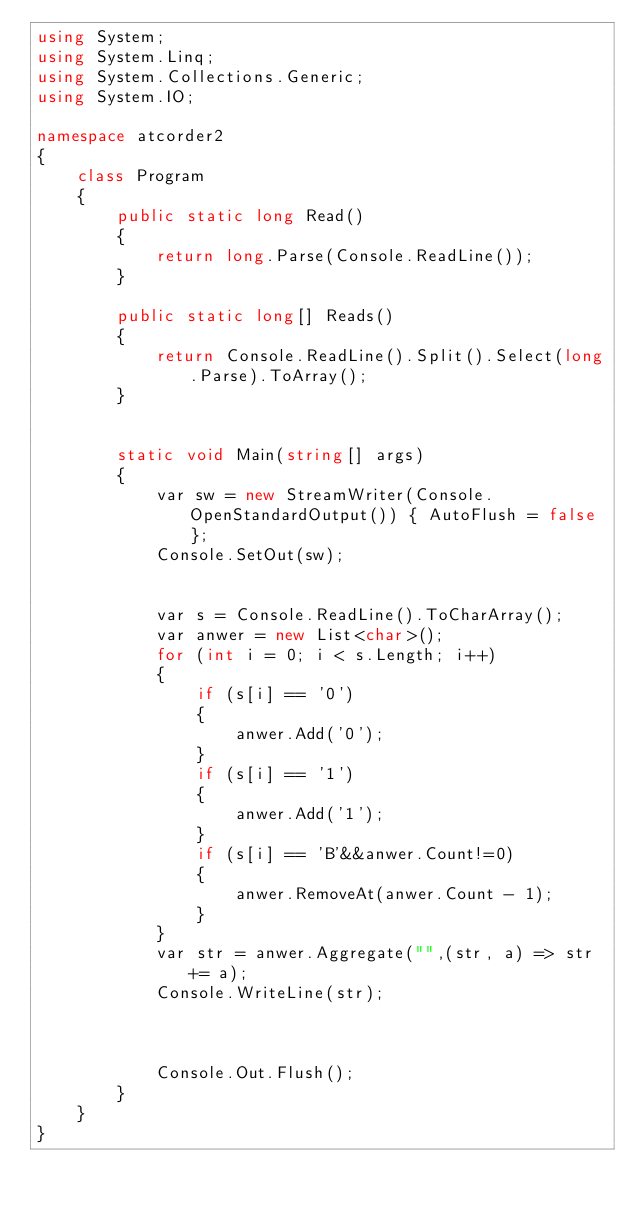Convert code to text. <code><loc_0><loc_0><loc_500><loc_500><_C#_>using System;
using System.Linq;
using System.Collections.Generic;
using System.IO;

namespace atcorder2
{
    class Program
    {
        public static long Read()
        {
            return long.Parse(Console.ReadLine());
        }

        public static long[] Reads()
        {
            return Console.ReadLine().Split().Select(long.Parse).ToArray();
        }
        

        static void Main(string[] args)
        {
            var sw = new StreamWriter(Console.OpenStandardOutput()) { AutoFlush = false };
            Console.SetOut(sw);


            var s = Console.ReadLine().ToCharArray();
            var anwer = new List<char>();
            for (int i = 0; i < s.Length; i++)
            {
                if (s[i] == '0')
                {
                    anwer.Add('0');
                }
                if (s[i] == '1')
                {
                    anwer.Add('1');
                }
                if (s[i] == 'B'&&anwer.Count!=0)
                {
                    anwer.RemoveAt(anwer.Count - 1);
                }
            }
            var str = anwer.Aggregate("",(str, a) => str += a);
            Console.WriteLine(str);
                   
        

            Console.Out.Flush();
        }
    }
}</code> 